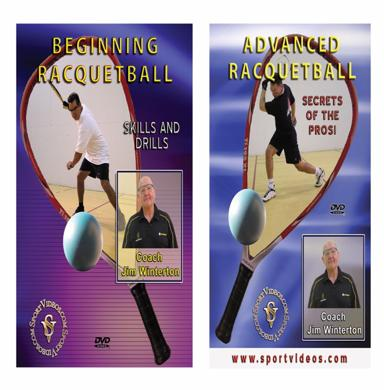Who is the target audience for each of these DVDs? The 'Beginning Racquetball' DVD is designed for beginners or those unfamiliar with racquetball, providing basic techniques and rules, ideal for newcomers. On the other hand, the 'Advanced Racquetball' DVD targets players who already have some experience and are looking to enhance their skills and strategies significantly. These DVDs ensure that everyone from beginners to seasoned players finds useful content to help them progress. 